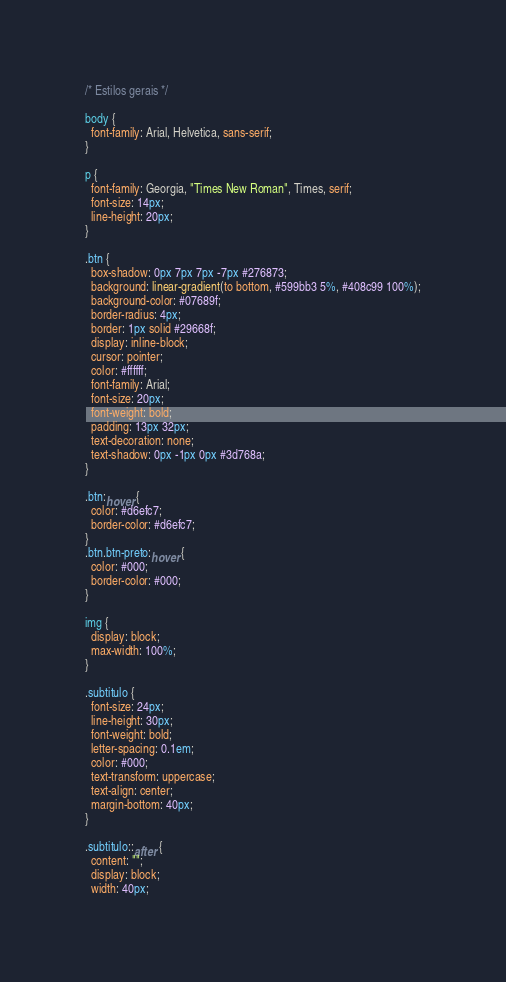<code> <loc_0><loc_0><loc_500><loc_500><_CSS_>/* Estilos gerais */

body {
  font-family: Arial, Helvetica, sans-serif;
}

p {
  font-family: Georgia, "Times New Roman", Times, serif;
  font-size: 14px;
  line-height: 20px;
}

.btn {
  box-shadow: 0px 7px 7px -7px #276873;
  background: linear-gradient(to bottom, #599bb3 5%, #408c99 100%);
  background-color: #07689f;
  border-radius: 4px;
  border: 1px solid #29668f;
  display: inline-block;
  cursor: pointer;
  color: #ffffff;
  font-family: Arial;
  font-size: 20px;
  font-weight: bold;
  padding: 13px 32px;
  text-decoration: none;
  text-shadow: 0px -1px 0px #3d768a;
}

.btn:hover {
  color: #d6efc7;
  border-color: #d6efc7;
}
.btn.btn-preto:hover {
  color: #000;
  border-color: #000;
}

img {
  display: block;
  max-width: 100%;
}

.subtitulo {
  font-size: 24px;
  line-height: 30px;
  font-weight: bold;
  letter-spacing: 0.1em;
  color: #000;
  text-transform: uppercase;
  text-align: center;
  margin-bottom: 40px;
}

.subtitulo::after {
  content: "";
  display: block;
  width: 40px;</code> 